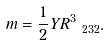Convert formula to latex. <formula><loc_0><loc_0><loc_500><loc_500>m = \frac { 1 } { 2 } Y R _ { \ 2 3 2 } ^ { 3 } .</formula> 